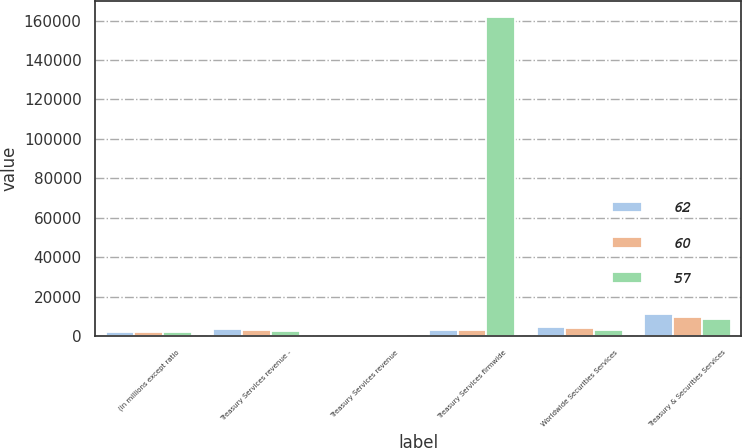Convert chart to OTSL. <chart><loc_0><loc_0><loc_500><loc_500><stacked_bar_chart><ecel><fcel>(in millions except ratio<fcel>Treasury Services revenue -<fcel>Treasury Services revenue<fcel>Treasury Services firmwide<fcel>Worldwide Securities Services<fcel>Treasury & Securities Services<nl><fcel>62<fcel>2008<fcel>3555<fcel>299<fcel>3165<fcel>4579<fcel>11081<nl><fcel>60<fcel>2007<fcel>3013<fcel>270<fcel>3165<fcel>3932<fcel>9565<nl><fcel>57<fcel>2006<fcel>2792<fcel>207<fcel>162020<fcel>3317<fcel>8559<nl></chart> 